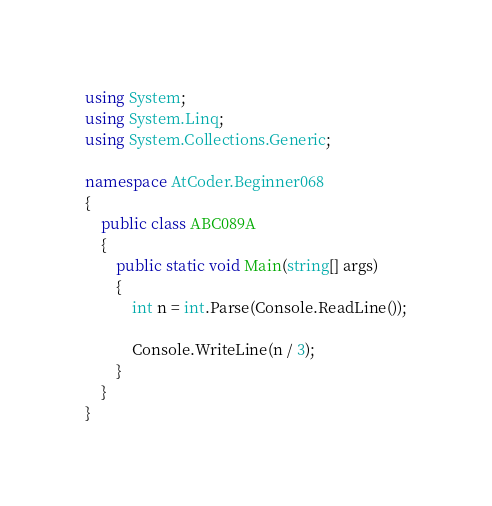Convert code to text. <code><loc_0><loc_0><loc_500><loc_500><_C#_>using System;
using System.Linq;
using System.Collections.Generic;

namespace AtCoder.Beginner068
{
    public class ABC089A
    {
        public static void Main(string[] args)
        {
            int n = int.Parse(Console.ReadLine());

            Console.WriteLine(n / 3);
        }
    }
}</code> 